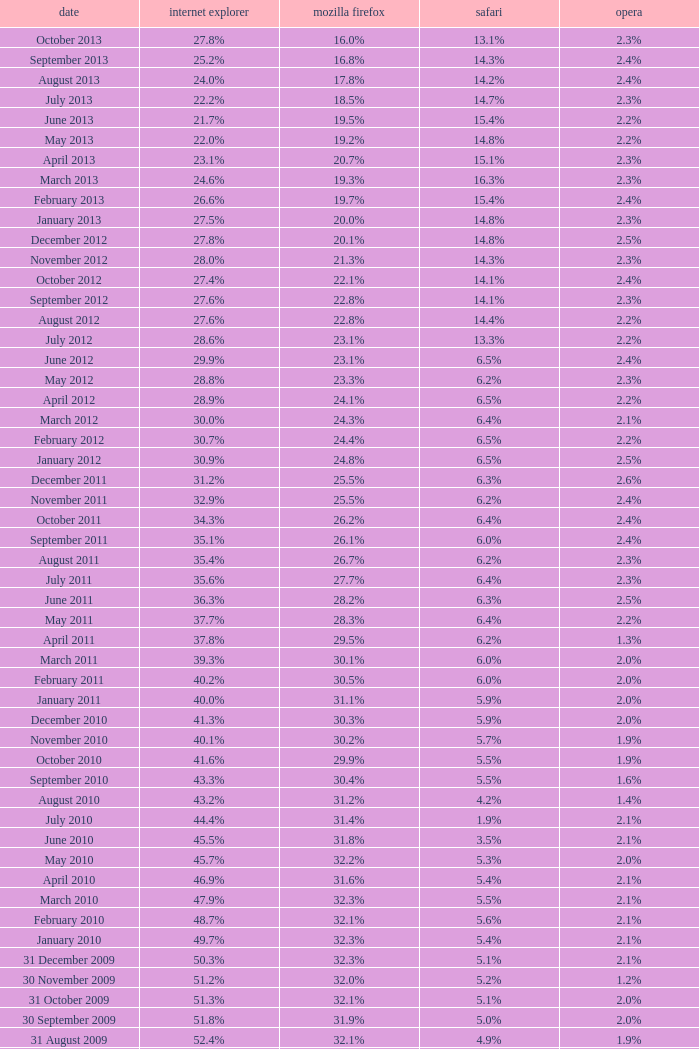What is the firefox value with a 1.9% safari? 31.4%. 